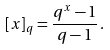<formula> <loc_0><loc_0><loc_500><loc_500>[ x ] _ { q } = \frac { q ^ { x } - 1 } { q - 1 } \, .</formula> 